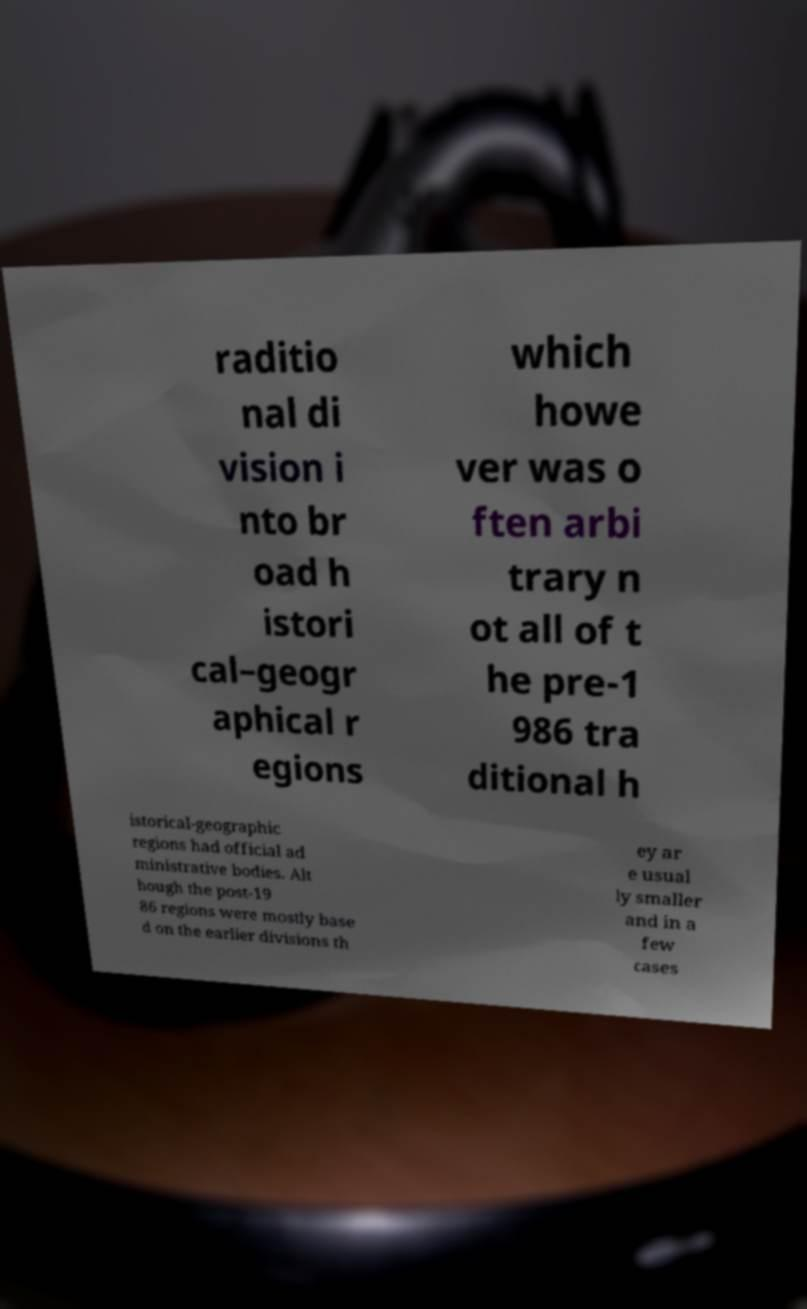What messages or text are displayed in this image? I need them in a readable, typed format. raditio nal di vision i nto br oad h istori cal–geogr aphical r egions which howe ver was o ften arbi trary n ot all of t he pre-1 986 tra ditional h istorical-geographic regions had official ad ministrative bodies. Alt hough the post-19 86 regions were mostly base d on the earlier divisions th ey ar e usual ly smaller and in a few cases 